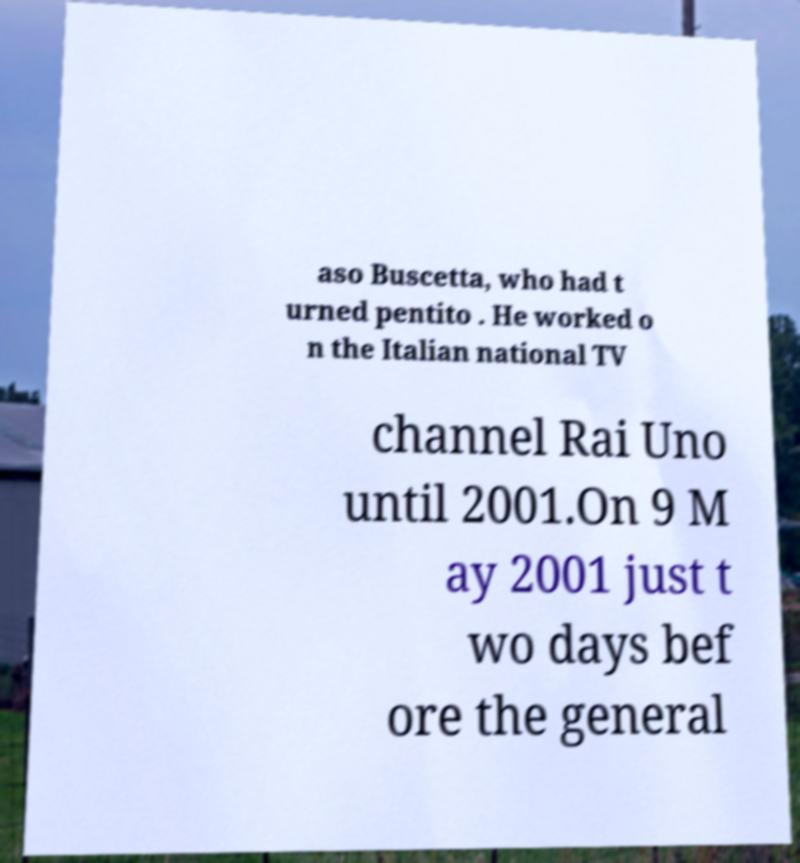For documentation purposes, I need the text within this image transcribed. Could you provide that? aso Buscetta, who had t urned pentito . He worked o n the Italian national TV channel Rai Uno until 2001.On 9 M ay 2001 just t wo days bef ore the general 